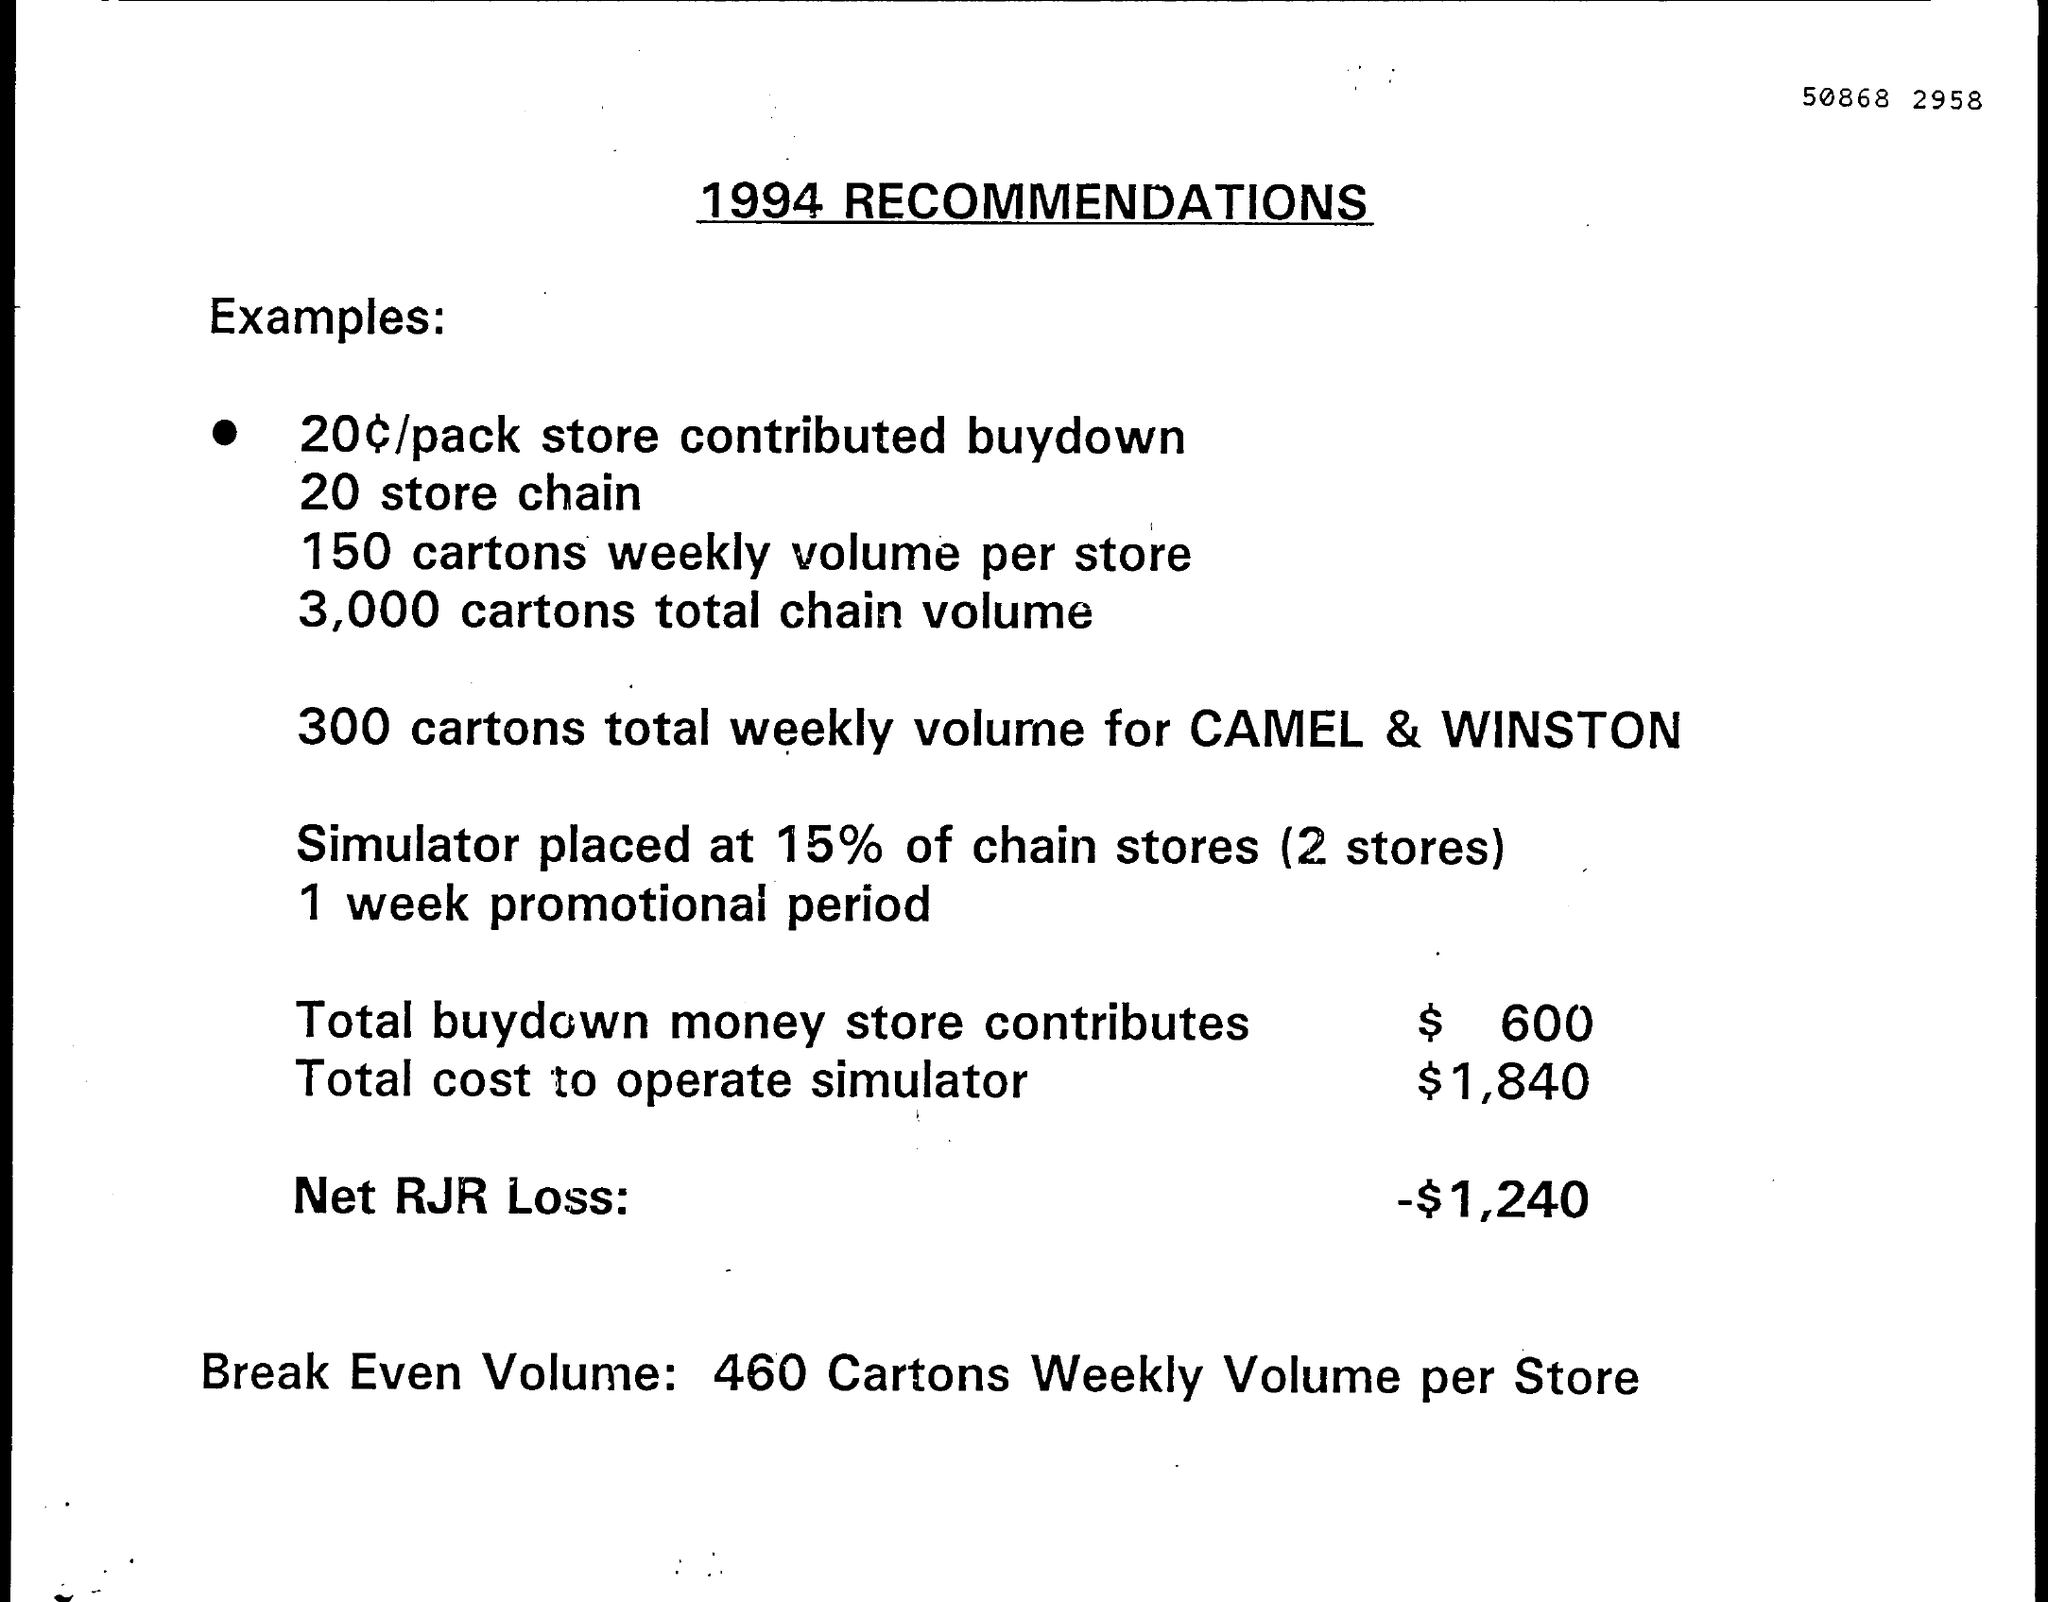What is the total cost to operate simulator?
Keep it short and to the point. $1,840. What is the total buydown money store contributes?
Give a very brief answer. $  600. What is the Net RJR Loss?
Offer a terse response. -$1,240. What is the Break Even Volume as per the document?
Ensure brevity in your answer.  460 Cartons Weekly Volume per Store. 